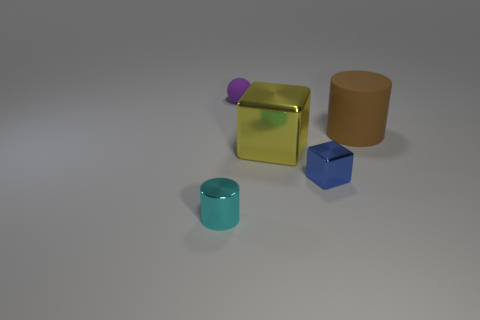Can you describe the colors and materials of the objects displayed in the image? Certainly! In the image, we have five objects, each with distinct colors and appearances. Starting from the left, there's a small, shiny teal cylinder. Moving right, we encounter a large, translucent yellow cube with a matte texture. On top of this cube rests a smaller, opaque purple sphere. To the right, there's a medium-sized, shiny blue cube, and finally, on the far right, we see a large, matte beige cylinder. Each object's material gives it a unique visual quality, enhancing the variety and vibrancy of the scene. 